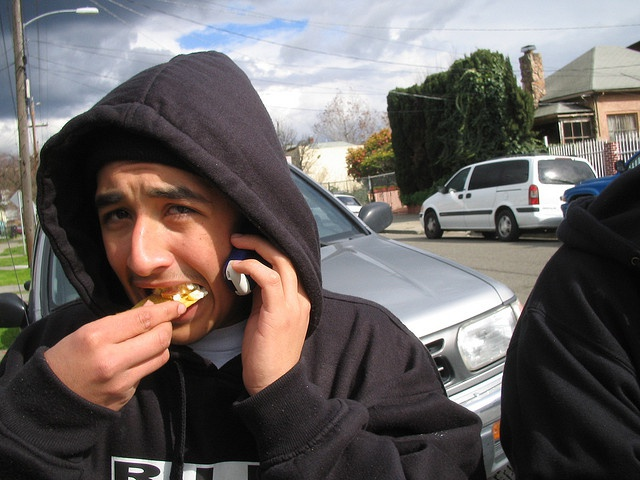Describe the objects in this image and their specific colors. I can see people in darkblue, black, gray, maroon, and tan tones, people in darkblue, black, navy, gray, and darkgray tones, car in darkblue, darkgray, white, gray, and black tones, car in darkblue, darkgray, black, white, and gray tones, and cell phone in darkblue, black, gray, and ivory tones in this image. 